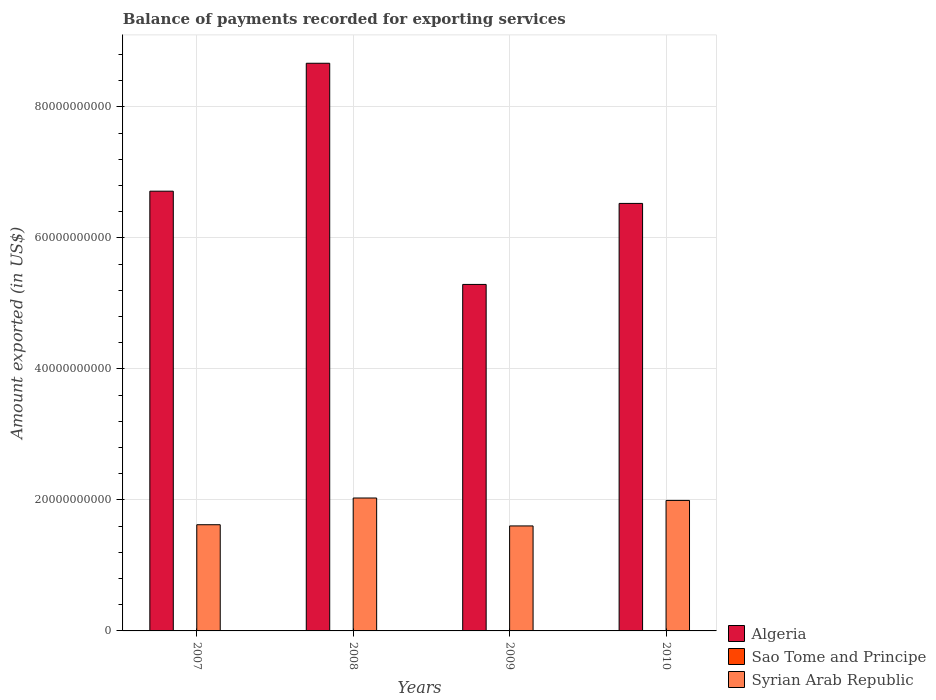How many different coloured bars are there?
Your answer should be compact. 3. How many groups of bars are there?
Ensure brevity in your answer.  4. Are the number of bars per tick equal to the number of legend labels?
Give a very brief answer. Yes. How many bars are there on the 1st tick from the right?
Offer a terse response. 3. In how many cases, is the number of bars for a given year not equal to the number of legend labels?
Your answer should be very brief. 0. What is the amount exported in Sao Tome and Principe in 2010?
Make the answer very short. 2.62e+07. Across all years, what is the maximum amount exported in Sao Tome and Principe?
Your answer should be very brief. 2.62e+07. Across all years, what is the minimum amount exported in Sao Tome and Principe?
Provide a short and direct response. 1.94e+07. In which year was the amount exported in Algeria minimum?
Offer a very short reply. 2009. What is the total amount exported in Sao Tome and Principe in the graph?
Your answer should be very brief. 8.72e+07. What is the difference between the amount exported in Syrian Arab Republic in 2009 and that in 2010?
Make the answer very short. -3.89e+09. What is the difference between the amount exported in Syrian Arab Republic in 2007 and the amount exported in Sao Tome and Principe in 2010?
Your response must be concise. 1.62e+1. What is the average amount exported in Syrian Arab Republic per year?
Offer a terse response. 1.81e+1. In the year 2009, what is the difference between the amount exported in Sao Tome and Principe and amount exported in Syrian Arab Republic?
Offer a terse response. -1.60e+1. What is the ratio of the amount exported in Sao Tome and Principe in 2009 to that in 2010?
Your answer should be compact. 0.81. Is the difference between the amount exported in Sao Tome and Principe in 2007 and 2009 greater than the difference between the amount exported in Syrian Arab Republic in 2007 and 2009?
Offer a terse response. No. What is the difference between the highest and the second highest amount exported in Sao Tome and Principe?
Offer a very short reply. 4.95e+06. What is the difference between the highest and the lowest amount exported in Syrian Arab Republic?
Your answer should be compact. 4.26e+09. In how many years, is the amount exported in Sao Tome and Principe greater than the average amount exported in Sao Tome and Principe taken over all years?
Offer a very short reply. 1. What does the 1st bar from the left in 2010 represents?
Provide a succinct answer. Algeria. What does the 2nd bar from the right in 2008 represents?
Provide a succinct answer. Sao Tome and Principe. How many bars are there?
Provide a short and direct response. 12. What is the difference between two consecutive major ticks on the Y-axis?
Give a very brief answer. 2.00e+1. Are the values on the major ticks of Y-axis written in scientific E-notation?
Your answer should be compact. No. How many legend labels are there?
Make the answer very short. 3. How are the legend labels stacked?
Provide a succinct answer. Vertical. What is the title of the graph?
Offer a very short reply. Balance of payments recorded for exporting services. What is the label or title of the Y-axis?
Your answer should be compact. Amount exported (in US$). What is the Amount exported (in US$) of Algeria in 2007?
Make the answer very short. 6.71e+1. What is the Amount exported (in US$) in Sao Tome and Principe in 2007?
Offer a terse response. 2.03e+07. What is the Amount exported (in US$) of Syrian Arab Republic in 2007?
Keep it short and to the point. 1.62e+1. What is the Amount exported (in US$) in Algeria in 2008?
Provide a short and direct response. 8.67e+1. What is the Amount exported (in US$) of Sao Tome and Principe in 2008?
Make the answer very short. 1.94e+07. What is the Amount exported (in US$) of Syrian Arab Republic in 2008?
Provide a short and direct response. 2.03e+1. What is the Amount exported (in US$) in Algeria in 2009?
Make the answer very short. 5.29e+1. What is the Amount exported (in US$) of Sao Tome and Principe in 2009?
Offer a terse response. 2.13e+07. What is the Amount exported (in US$) of Syrian Arab Republic in 2009?
Provide a short and direct response. 1.60e+1. What is the Amount exported (in US$) in Algeria in 2010?
Your answer should be very brief. 6.53e+1. What is the Amount exported (in US$) of Sao Tome and Principe in 2010?
Give a very brief answer. 2.62e+07. What is the Amount exported (in US$) in Syrian Arab Republic in 2010?
Give a very brief answer. 1.99e+1. Across all years, what is the maximum Amount exported (in US$) in Algeria?
Ensure brevity in your answer.  8.67e+1. Across all years, what is the maximum Amount exported (in US$) in Sao Tome and Principe?
Keep it short and to the point. 2.62e+07. Across all years, what is the maximum Amount exported (in US$) in Syrian Arab Republic?
Give a very brief answer. 2.03e+1. Across all years, what is the minimum Amount exported (in US$) of Algeria?
Offer a terse response. 5.29e+1. Across all years, what is the minimum Amount exported (in US$) of Sao Tome and Principe?
Keep it short and to the point. 1.94e+07. Across all years, what is the minimum Amount exported (in US$) in Syrian Arab Republic?
Ensure brevity in your answer.  1.60e+1. What is the total Amount exported (in US$) in Algeria in the graph?
Offer a terse response. 2.72e+11. What is the total Amount exported (in US$) in Sao Tome and Principe in the graph?
Provide a succinct answer. 8.72e+07. What is the total Amount exported (in US$) of Syrian Arab Republic in the graph?
Give a very brief answer. 7.24e+1. What is the difference between the Amount exported (in US$) of Algeria in 2007 and that in 2008?
Provide a short and direct response. -1.95e+1. What is the difference between the Amount exported (in US$) of Sao Tome and Principe in 2007 and that in 2008?
Your answer should be compact. 8.26e+05. What is the difference between the Amount exported (in US$) of Syrian Arab Republic in 2007 and that in 2008?
Your answer should be very brief. -4.08e+09. What is the difference between the Amount exported (in US$) in Algeria in 2007 and that in 2009?
Ensure brevity in your answer.  1.42e+1. What is the difference between the Amount exported (in US$) in Sao Tome and Principe in 2007 and that in 2009?
Give a very brief answer. -9.81e+05. What is the difference between the Amount exported (in US$) in Syrian Arab Republic in 2007 and that in 2009?
Offer a terse response. 1.85e+08. What is the difference between the Amount exported (in US$) in Algeria in 2007 and that in 2010?
Your answer should be compact. 1.87e+09. What is the difference between the Amount exported (in US$) in Sao Tome and Principe in 2007 and that in 2010?
Give a very brief answer. -5.93e+06. What is the difference between the Amount exported (in US$) in Syrian Arab Republic in 2007 and that in 2010?
Your answer should be compact. -3.71e+09. What is the difference between the Amount exported (in US$) in Algeria in 2008 and that in 2009?
Keep it short and to the point. 3.38e+1. What is the difference between the Amount exported (in US$) of Sao Tome and Principe in 2008 and that in 2009?
Your answer should be compact. -1.81e+06. What is the difference between the Amount exported (in US$) of Syrian Arab Republic in 2008 and that in 2009?
Keep it short and to the point. 4.26e+09. What is the difference between the Amount exported (in US$) of Algeria in 2008 and that in 2010?
Provide a succinct answer. 2.14e+1. What is the difference between the Amount exported (in US$) in Sao Tome and Principe in 2008 and that in 2010?
Make the answer very short. -6.76e+06. What is the difference between the Amount exported (in US$) of Syrian Arab Republic in 2008 and that in 2010?
Provide a succinct answer. 3.71e+08. What is the difference between the Amount exported (in US$) of Algeria in 2009 and that in 2010?
Your answer should be very brief. -1.24e+1. What is the difference between the Amount exported (in US$) in Sao Tome and Principe in 2009 and that in 2010?
Your response must be concise. -4.95e+06. What is the difference between the Amount exported (in US$) of Syrian Arab Republic in 2009 and that in 2010?
Keep it short and to the point. -3.89e+09. What is the difference between the Amount exported (in US$) of Algeria in 2007 and the Amount exported (in US$) of Sao Tome and Principe in 2008?
Your response must be concise. 6.71e+1. What is the difference between the Amount exported (in US$) of Algeria in 2007 and the Amount exported (in US$) of Syrian Arab Republic in 2008?
Offer a very short reply. 4.68e+1. What is the difference between the Amount exported (in US$) in Sao Tome and Principe in 2007 and the Amount exported (in US$) in Syrian Arab Republic in 2008?
Provide a succinct answer. -2.03e+1. What is the difference between the Amount exported (in US$) of Algeria in 2007 and the Amount exported (in US$) of Sao Tome and Principe in 2009?
Offer a terse response. 6.71e+1. What is the difference between the Amount exported (in US$) of Algeria in 2007 and the Amount exported (in US$) of Syrian Arab Republic in 2009?
Make the answer very short. 5.11e+1. What is the difference between the Amount exported (in US$) in Sao Tome and Principe in 2007 and the Amount exported (in US$) in Syrian Arab Republic in 2009?
Make the answer very short. -1.60e+1. What is the difference between the Amount exported (in US$) of Algeria in 2007 and the Amount exported (in US$) of Sao Tome and Principe in 2010?
Provide a short and direct response. 6.71e+1. What is the difference between the Amount exported (in US$) of Algeria in 2007 and the Amount exported (in US$) of Syrian Arab Republic in 2010?
Offer a very short reply. 4.72e+1. What is the difference between the Amount exported (in US$) in Sao Tome and Principe in 2007 and the Amount exported (in US$) in Syrian Arab Republic in 2010?
Provide a short and direct response. -1.99e+1. What is the difference between the Amount exported (in US$) of Algeria in 2008 and the Amount exported (in US$) of Sao Tome and Principe in 2009?
Your response must be concise. 8.66e+1. What is the difference between the Amount exported (in US$) of Algeria in 2008 and the Amount exported (in US$) of Syrian Arab Republic in 2009?
Make the answer very short. 7.06e+1. What is the difference between the Amount exported (in US$) in Sao Tome and Principe in 2008 and the Amount exported (in US$) in Syrian Arab Republic in 2009?
Provide a succinct answer. -1.60e+1. What is the difference between the Amount exported (in US$) of Algeria in 2008 and the Amount exported (in US$) of Sao Tome and Principe in 2010?
Give a very brief answer. 8.66e+1. What is the difference between the Amount exported (in US$) in Algeria in 2008 and the Amount exported (in US$) in Syrian Arab Republic in 2010?
Provide a short and direct response. 6.67e+1. What is the difference between the Amount exported (in US$) in Sao Tome and Principe in 2008 and the Amount exported (in US$) in Syrian Arab Republic in 2010?
Ensure brevity in your answer.  -1.99e+1. What is the difference between the Amount exported (in US$) of Algeria in 2009 and the Amount exported (in US$) of Sao Tome and Principe in 2010?
Ensure brevity in your answer.  5.29e+1. What is the difference between the Amount exported (in US$) of Algeria in 2009 and the Amount exported (in US$) of Syrian Arab Republic in 2010?
Provide a succinct answer. 3.30e+1. What is the difference between the Amount exported (in US$) of Sao Tome and Principe in 2009 and the Amount exported (in US$) of Syrian Arab Republic in 2010?
Provide a short and direct response. -1.99e+1. What is the average Amount exported (in US$) in Algeria per year?
Your answer should be compact. 6.80e+1. What is the average Amount exported (in US$) of Sao Tome and Principe per year?
Provide a succinct answer. 2.18e+07. What is the average Amount exported (in US$) in Syrian Arab Republic per year?
Offer a terse response. 1.81e+1. In the year 2007, what is the difference between the Amount exported (in US$) in Algeria and Amount exported (in US$) in Sao Tome and Principe?
Give a very brief answer. 6.71e+1. In the year 2007, what is the difference between the Amount exported (in US$) of Algeria and Amount exported (in US$) of Syrian Arab Republic?
Your answer should be compact. 5.09e+1. In the year 2007, what is the difference between the Amount exported (in US$) in Sao Tome and Principe and Amount exported (in US$) in Syrian Arab Republic?
Your response must be concise. -1.62e+1. In the year 2008, what is the difference between the Amount exported (in US$) in Algeria and Amount exported (in US$) in Sao Tome and Principe?
Offer a very short reply. 8.66e+1. In the year 2008, what is the difference between the Amount exported (in US$) of Algeria and Amount exported (in US$) of Syrian Arab Republic?
Keep it short and to the point. 6.64e+1. In the year 2008, what is the difference between the Amount exported (in US$) of Sao Tome and Principe and Amount exported (in US$) of Syrian Arab Republic?
Your answer should be very brief. -2.03e+1. In the year 2009, what is the difference between the Amount exported (in US$) in Algeria and Amount exported (in US$) in Sao Tome and Principe?
Provide a succinct answer. 5.29e+1. In the year 2009, what is the difference between the Amount exported (in US$) of Algeria and Amount exported (in US$) of Syrian Arab Republic?
Keep it short and to the point. 3.69e+1. In the year 2009, what is the difference between the Amount exported (in US$) of Sao Tome and Principe and Amount exported (in US$) of Syrian Arab Republic?
Make the answer very short. -1.60e+1. In the year 2010, what is the difference between the Amount exported (in US$) in Algeria and Amount exported (in US$) in Sao Tome and Principe?
Provide a succinct answer. 6.52e+1. In the year 2010, what is the difference between the Amount exported (in US$) in Algeria and Amount exported (in US$) in Syrian Arab Republic?
Make the answer very short. 4.53e+1. In the year 2010, what is the difference between the Amount exported (in US$) in Sao Tome and Principe and Amount exported (in US$) in Syrian Arab Republic?
Provide a short and direct response. -1.99e+1. What is the ratio of the Amount exported (in US$) of Algeria in 2007 to that in 2008?
Ensure brevity in your answer.  0.77. What is the ratio of the Amount exported (in US$) in Sao Tome and Principe in 2007 to that in 2008?
Ensure brevity in your answer.  1.04. What is the ratio of the Amount exported (in US$) of Syrian Arab Republic in 2007 to that in 2008?
Offer a terse response. 0.8. What is the ratio of the Amount exported (in US$) of Algeria in 2007 to that in 2009?
Ensure brevity in your answer.  1.27. What is the ratio of the Amount exported (in US$) in Sao Tome and Principe in 2007 to that in 2009?
Offer a terse response. 0.95. What is the ratio of the Amount exported (in US$) in Syrian Arab Republic in 2007 to that in 2009?
Your answer should be compact. 1.01. What is the ratio of the Amount exported (in US$) of Algeria in 2007 to that in 2010?
Your response must be concise. 1.03. What is the ratio of the Amount exported (in US$) of Sao Tome and Principe in 2007 to that in 2010?
Keep it short and to the point. 0.77. What is the ratio of the Amount exported (in US$) of Syrian Arab Republic in 2007 to that in 2010?
Give a very brief answer. 0.81. What is the ratio of the Amount exported (in US$) of Algeria in 2008 to that in 2009?
Provide a short and direct response. 1.64. What is the ratio of the Amount exported (in US$) in Sao Tome and Principe in 2008 to that in 2009?
Offer a terse response. 0.92. What is the ratio of the Amount exported (in US$) in Syrian Arab Republic in 2008 to that in 2009?
Keep it short and to the point. 1.27. What is the ratio of the Amount exported (in US$) of Algeria in 2008 to that in 2010?
Your answer should be very brief. 1.33. What is the ratio of the Amount exported (in US$) in Sao Tome and Principe in 2008 to that in 2010?
Offer a very short reply. 0.74. What is the ratio of the Amount exported (in US$) of Syrian Arab Republic in 2008 to that in 2010?
Give a very brief answer. 1.02. What is the ratio of the Amount exported (in US$) of Algeria in 2009 to that in 2010?
Your answer should be very brief. 0.81. What is the ratio of the Amount exported (in US$) in Sao Tome and Principe in 2009 to that in 2010?
Offer a very short reply. 0.81. What is the ratio of the Amount exported (in US$) in Syrian Arab Republic in 2009 to that in 2010?
Your answer should be very brief. 0.8. What is the difference between the highest and the second highest Amount exported (in US$) in Algeria?
Offer a very short reply. 1.95e+1. What is the difference between the highest and the second highest Amount exported (in US$) of Sao Tome and Principe?
Give a very brief answer. 4.95e+06. What is the difference between the highest and the second highest Amount exported (in US$) in Syrian Arab Republic?
Provide a succinct answer. 3.71e+08. What is the difference between the highest and the lowest Amount exported (in US$) of Algeria?
Make the answer very short. 3.38e+1. What is the difference between the highest and the lowest Amount exported (in US$) of Sao Tome and Principe?
Offer a very short reply. 6.76e+06. What is the difference between the highest and the lowest Amount exported (in US$) of Syrian Arab Republic?
Offer a very short reply. 4.26e+09. 